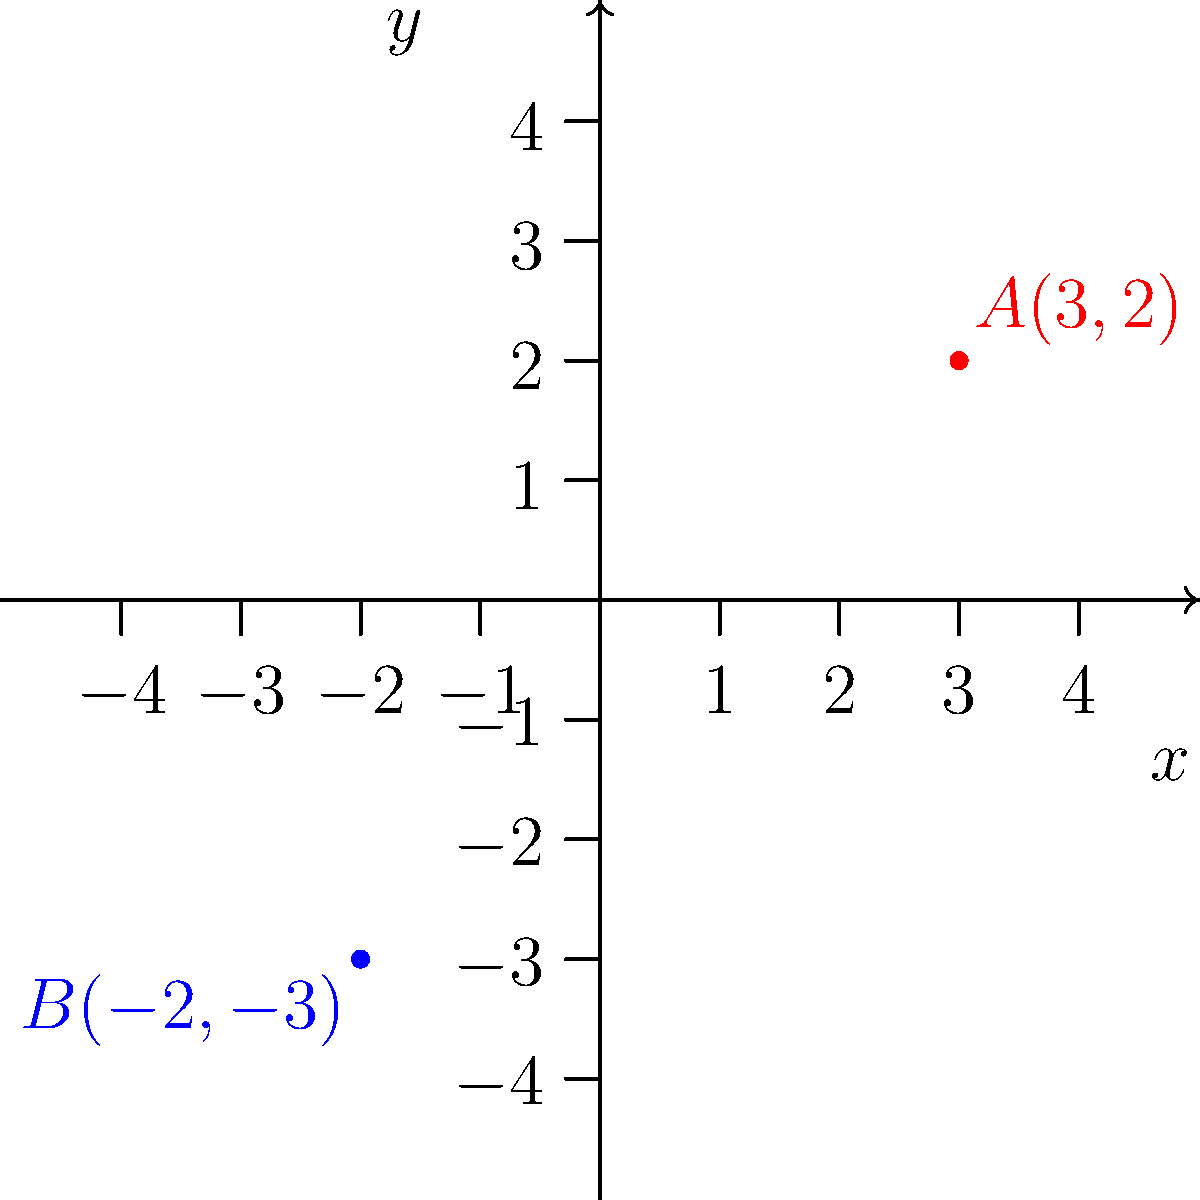Look at the coordinate plane above. Point A is located at (3,2) and point B is at (-2,-3). Which quadrants do these points belong to? To determine the quadrants of points A and B, we need to follow these steps:

1. Recall the quadrant definitions:
   - Quadrant I: Both x and y are positive (+,+)
   - Quadrant II: x is negative, y is positive (-,+)
   - Quadrant III: Both x and y are negative (-,-)
   - Quadrant IV: x is positive, y is negative (+,-)

2. For point A(3,2):
   - x-coordinate (3) is positive
   - y-coordinate (2) is positive
   - Since both coordinates are positive, A is in Quadrant I

3. For point B(-2,-3):
   - x-coordinate (-2) is negative
   - y-coordinate (-3) is negative
   - Since both coordinates are negative, B is in Quadrant III

Therefore, point A is in Quadrant I, and point B is in Quadrant III.
Answer: A: Quadrant I, B: Quadrant III 